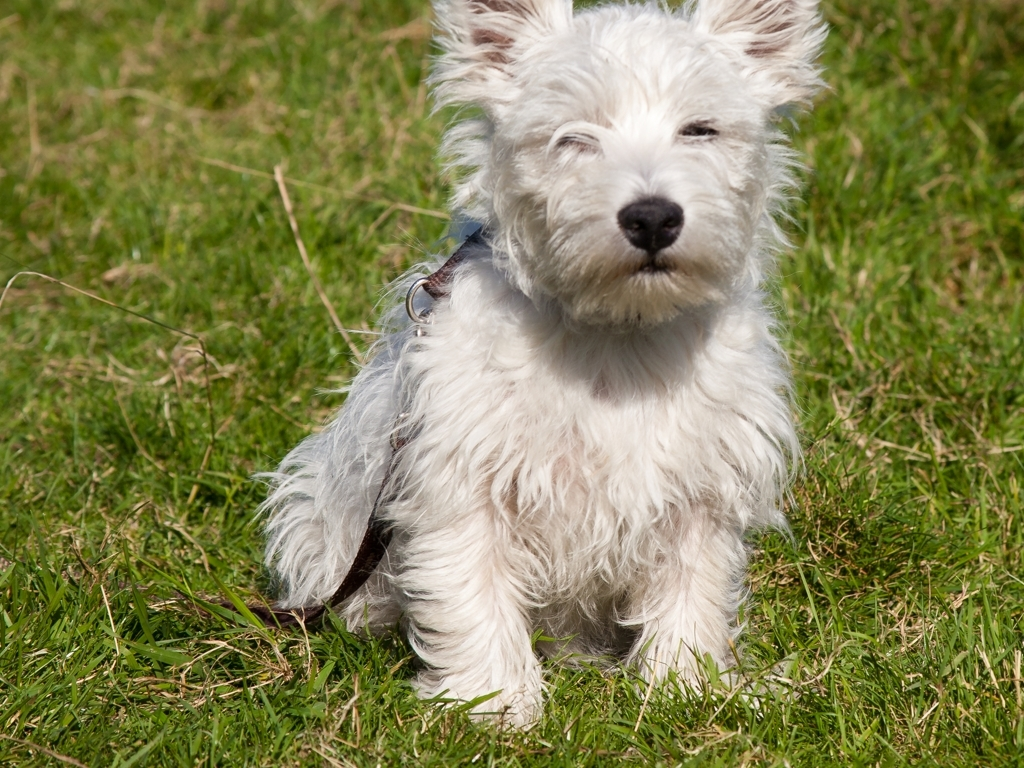Describe the mood of this image based on the dog's expression. The dog's expression conveys a sense of contentment and relaxation. With its eyes gently closed and the relaxed posture on the sunlit grass, the dog seems very much at ease. The setting suggests a tranquil, serene moment, typical of a leisurely day outdoors. What might this image indicate about the dog's care? The well-groomed fur, the dog's healthy appearance, and the secure environment suggest attentive care. The dog seems well taken care of, indicating that the owner likely ensures it receives proper nutrition, grooming, and affection, which are vital for its well-being. 